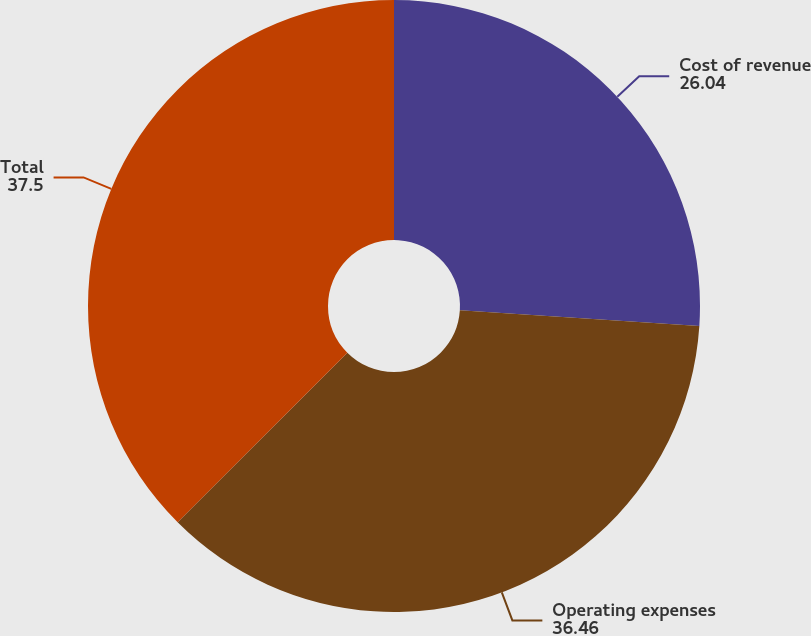Convert chart to OTSL. <chart><loc_0><loc_0><loc_500><loc_500><pie_chart><fcel>Cost of revenue<fcel>Operating expenses<fcel>Total<nl><fcel>26.04%<fcel>36.46%<fcel>37.5%<nl></chart> 